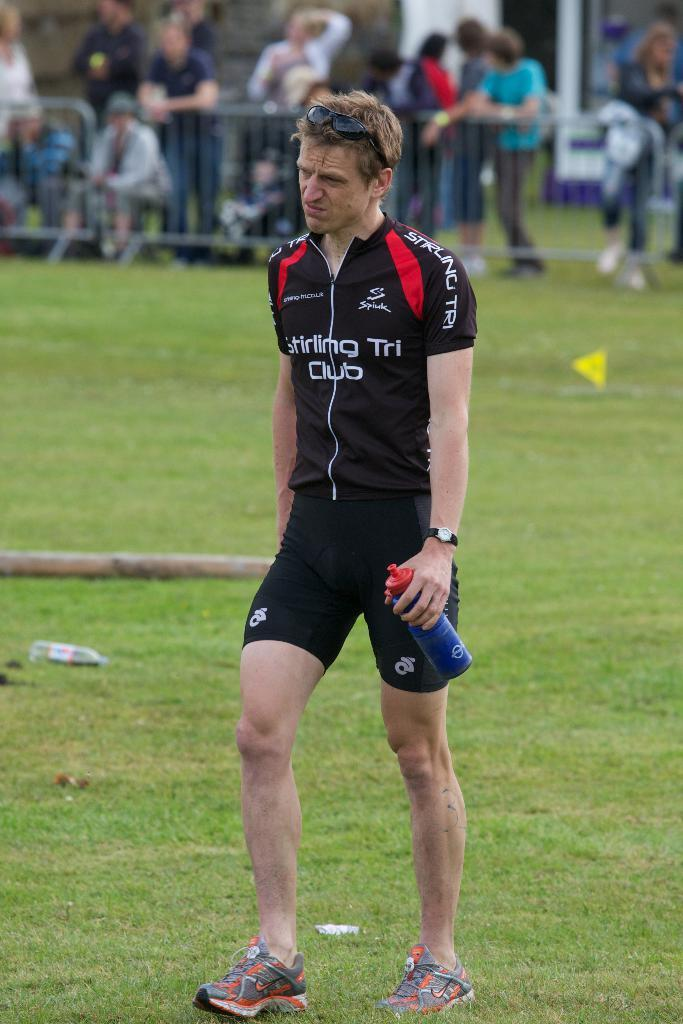<image>
Offer a succinct explanation of the picture presented. Man wearing a black jersey that says "Stirling Tri Club" holding a bottle. 